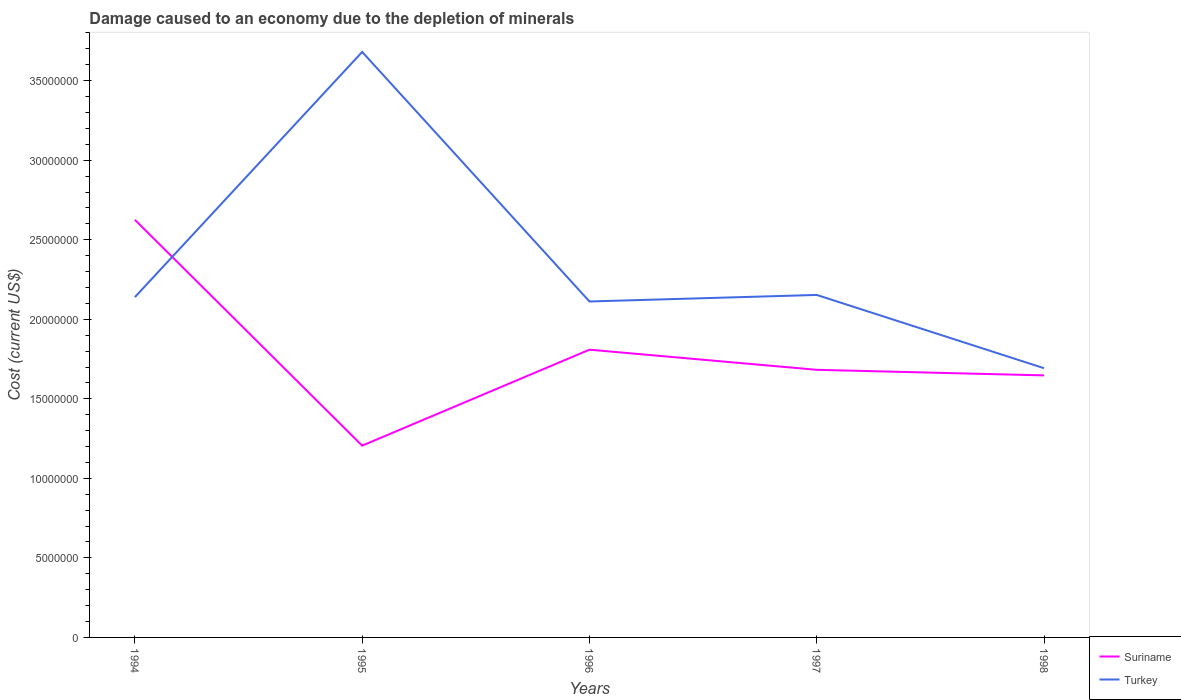How many different coloured lines are there?
Provide a succinct answer. 2. Is the number of lines equal to the number of legend labels?
Provide a succinct answer. Yes. Across all years, what is the maximum cost of damage caused due to the depletion of minerals in Suriname?
Provide a succinct answer. 1.21e+07. What is the total cost of damage caused due to the depletion of minerals in Suriname in the graph?
Provide a succinct answer. -6.03e+06. What is the difference between the highest and the second highest cost of damage caused due to the depletion of minerals in Suriname?
Your answer should be very brief. 1.42e+07. How many lines are there?
Your answer should be very brief. 2. How many years are there in the graph?
Offer a terse response. 5. What is the difference between two consecutive major ticks on the Y-axis?
Your answer should be very brief. 5.00e+06. Are the values on the major ticks of Y-axis written in scientific E-notation?
Offer a terse response. No. Does the graph contain any zero values?
Give a very brief answer. No. How many legend labels are there?
Offer a very short reply. 2. What is the title of the graph?
Offer a very short reply. Damage caused to an economy due to the depletion of minerals. Does "Argentina" appear as one of the legend labels in the graph?
Keep it short and to the point. No. What is the label or title of the Y-axis?
Provide a succinct answer. Cost (current US$). What is the Cost (current US$) of Suriname in 1994?
Your response must be concise. 2.63e+07. What is the Cost (current US$) of Turkey in 1994?
Offer a very short reply. 2.14e+07. What is the Cost (current US$) in Suriname in 1995?
Offer a terse response. 1.21e+07. What is the Cost (current US$) in Turkey in 1995?
Provide a succinct answer. 3.68e+07. What is the Cost (current US$) of Suriname in 1996?
Offer a very short reply. 1.81e+07. What is the Cost (current US$) of Turkey in 1996?
Give a very brief answer. 2.11e+07. What is the Cost (current US$) in Suriname in 1997?
Your answer should be very brief. 1.68e+07. What is the Cost (current US$) in Turkey in 1997?
Offer a very short reply. 2.15e+07. What is the Cost (current US$) of Suriname in 1998?
Provide a short and direct response. 1.65e+07. What is the Cost (current US$) of Turkey in 1998?
Make the answer very short. 1.69e+07. Across all years, what is the maximum Cost (current US$) of Suriname?
Provide a succinct answer. 2.63e+07. Across all years, what is the maximum Cost (current US$) in Turkey?
Provide a short and direct response. 3.68e+07. Across all years, what is the minimum Cost (current US$) of Suriname?
Make the answer very short. 1.21e+07. Across all years, what is the minimum Cost (current US$) in Turkey?
Make the answer very short. 1.69e+07. What is the total Cost (current US$) in Suriname in the graph?
Ensure brevity in your answer.  8.97e+07. What is the total Cost (current US$) in Turkey in the graph?
Your response must be concise. 1.18e+08. What is the difference between the Cost (current US$) of Suriname in 1994 and that in 1995?
Offer a terse response. 1.42e+07. What is the difference between the Cost (current US$) in Turkey in 1994 and that in 1995?
Provide a succinct answer. -1.54e+07. What is the difference between the Cost (current US$) in Suriname in 1994 and that in 1996?
Offer a very short reply. 8.16e+06. What is the difference between the Cost (current US$) of Turkey in 1994 and that in 1996?
Ensure brevity in your answer.  2.74e+05. What is the difference between the Cost (current US$) in Suriname in 1994 and that in 1997?
Provide a short and direct response. 9.43e+06. What is the difference between the Cost (current US$) in Turkey in 1994 and that in 1997?
Your response must be concise. -1.37e+05. What is the difference between the Cost (current US$) in Suriname in 1994 and that in 1998?
Keep it short and to the point. 9.78e+06. What is the difference between the Cost (current US$) in Turkey in 1994 and that in 1998?
Your answer should be compact. 4.47e+06. What is the difference between the Cost (current US$) in Suriname in 1995 and that in 1996?
Give a very brief answer. -6.03e+06. What is the difference between the Cost (current US$) in Turkey in 1995 and that in 1996?
Provide a short and direct response. 1.57e+07. What is the difference between the Cost (current US$) of Suriname in 1995 and that in 1997?
Ensure brevity in your answer.  -4.77e+06. What is the difference between the Cost (current US$) in Turkey in 1995 and that in 1997?
Give a very brief answer. 1.53e+07. What is the difference between the Cost (current US$) of Suriname in 1995 and that in 1998?
Ensure brevity in your answer.  -4.42e+06. What is the difference between the Cost (current US$) of Turkey in 1995 and that in 1998?
Provide a succinct answer. 1.99e+07. What is the difference between the Cost (current US$) of Suriname in 1996 and that in 1997?
Provide a short and direct response. 1.27e+06. What is the difference between the Cost (current US$) in Turkey in 1996 and that in 1997?
Offer a very short reply. -4.11e+05. What is the difference between the Cost (current US$) of Suriname in 1996 and that in 1998?
Your answer should be compact. 1.62e+06. What is the difference between the Cost (current US$) in Turkey in 1996 and that in 1998?
Your answer should be compact. 4.19e+06. What is the difference between the Cost (current US$) in Suriname in 1997 and that in 1998?
Give a very brief answer. 3.51e+05. What is the difference between the Cost (current US$) in Turkey in 1997 and that in 1998?
Ensure brevity in your answer.  4.61e+06. What is the difference between the Cost (current US$) in Suriname in 1994 and the Cost (current US$) in Turkey in 1995?
Your answer should be very brief. -1.06e+07. What is the difference between the Cost (current US$) of Suriname in 1994 and the Cost (current US$) of Turkey in 1996?
Offer a terse response. 5.13e+06. What is the difference between the Cost (current US$) of Suriname in 1994 and the Cost (current US$) of Turkey in 1997?
Offer a terse response. 4.72e+06. What is the difference between the Cost (current US$) in Suriname in 1994 and the Cost (current US$) in Turkey in 1998?
Your answer should be compact. 9.33e+06. What is the difference between the Cost (current US$) in Suriname in 1995 and the Cost (current US$) in Turkey in 1996?
Your answer should be very brief. -9.06e+06. What is the difference between the Cost (current US$) in Suriname in 1995 and the Cost (current US$) in Turkey in 1997?
Make the answer very short. -9.47e+06. What is the difference between the Cost (current US$) of Suriname in 1995 and the Cost (current US$) of Turkey in 1998?
Provide a short and direct response. -4.87e+06. What is the difference between the Cost (current US$) of Suriname in 1996 and the Cost (current US$) of Turkey in 1997?
Offer a terse response. -3.44e+06. What is the difference between the Cost (current US$) in Suriname in 1996 and the Cost (current US$) in Turkey in 1998?
Your answer should be very brief. 1.16e+06. What is the difference between the Cost (current US$) in Suriname in 1997 and the Cost (current US$) in Turkey in 1998?
Your answer should be very brief. -1.01e+05. What is the average Cost (current US$) of Suriname per year?
Give a very brief answer. 1.79e+07. What is the average Cost (current US$) of Turkey per year?
Provide a succinct answer. 2.36e+07. In the year 1994, what is the difference between the Cost (current US$) in Suriname and Cost (current US$) in Turkey?
Keep it short and to the point. 4.86e+06. In the year 1995, what is the difference between the Cost (current US$) in Suriname and Cost (current US$) in Turkey?
Provide a succinct answer. -2.48e+07. In the year 1996, what is the difference between the Cost (current US$) of Suriname and Cost (current US$) of Turkey?
Your answer should be compact. -3.03e+06. In the year 1997, what is the difference between the Cost (current US$) in Suriname and Cost (current US$) in Turkey?
Ensure brevity in your answer.  -4.71e+06. In the year 1998, what is the difference between the Cost (current US$) of Suriname and Cost (current US$) of Turkey?
Keep it short and to the point. -4.52e+05. What is the ratio of the Cost (current US$) in Suriname in 1994 to that in 1995?
Make the answer very short. 2.18. What is the ratio of the Cost (current US$) in Turkey in 1994 to that in 1995?
Ensure brevity in your answer.  0.58. What is the ratio of the Cost (current US$) in Suriname in 1994 to that in 1996?
Offer a very short reply. 1.45. What is the ratio of the Cost (current US$) of Turkey in 1994 to that in 1996?
Your response must be concise. 1.01. What is the ratio of the Cost (current US$) in Suriname in 1994 to that in 1997?
Provide a short and direct response. 1.56. What is the ratio of the Cost (current US$) of Suriname in 1994 to that in 1998?
Your answer should be very brief. 1.59. What is the ratio of the Cost (current US$) of Turkey in 1994 to that in 1998?
Your answer should be very brief. 1.26. What is the ratio of the Cost (current US$) of Suriname in 1995 to that in 1996?
Your answer should be very brief. 0.67. What is the ratio of the Cost (current US$) of Turkey in 1995 to that in 1996?
Offer a very short reply. 1.74. What is the ratio of the Cost (current US$) in Suriname in 1995 to that in 1997?
Make the answer very short. 0.72. What is the ratio of the Cost (current US$) in Turkey in 1995 to that in 1997?
Your answer should be very brief. 1.71. What is the ratio of the Cost (current US$) in Suriname in 1995 to that in 1998?
Your answer should be very brief. 0.73. What is the ratio of the Cost (current US$) in Turkey in 1995 to that in 1998?
Your response must be concise. 2.17. What is the ratio of the Cost (current US$) of Suriname in 1996 to that in 1997?
Your answer should be compact. 1.08. What is the ratio of the Cost (current US$) in Turkey in 1996 to that in 1997?
Offer a very short reply. 0.98. What is the ratio of the Cost (current US$) of Suriname in 1996 to that in 1998?
Offer a terse response. 1.1. What is the ratio of the Cost (current US$) of Turkey in 1996 to that in 1998?
Make the answer very short. 1.25. What is the ratio of the Cost (current US$) in Suriname in 1997 to that in 1998?
Offer a very short reply. 1.02. What is the ratio of the Cost (current US$) in Turkey in 1997 to that in 1998?
Keep it short and to the point. 1.27. What is the difference between the highest and the second highest Cost (current US$) of Suriname?
Offer a very short reply. 8.16e+06. What is the difference between the highest and the second highest Cost (current US$) of Turkey?
Offer a terse response. 1.53e+07. What is the difference between the highest and the lowest Cost (current US$) in Suriname?
Give a very brief answer. 1.42e+07. What is the difference between the highest and the lowest Cost (current US$) of Turkey?
Your response must be concise. 1.99e+07. 